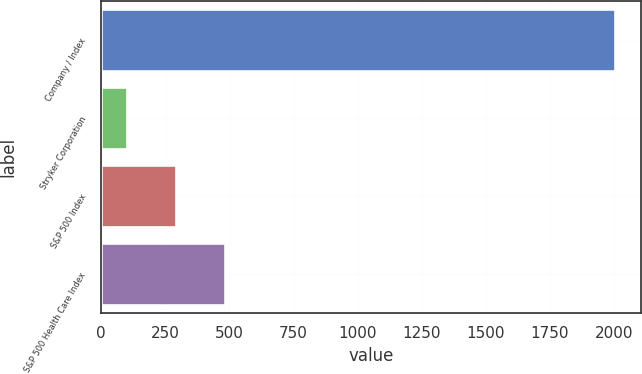Convert chart. <chart><loc_0><loc_0><loc_500><loc_500><bar_chart><fcel>Company / Index<fcel>Stryker Corporation<fcel>S&P 500 Index<fcel>S&P 500 Health Care Index<nl><fcel>2005<fcel>100<fcel>290.5<fcel>481<nl></chart> 